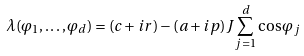<formula> <loc_0><loc_0><loc_500><loc_500>\lambda ( \varphi _ { 1 } , \dots , \varphi _ { d } ) = ( c + i r ) - ( a + i p ) J \sum _ { j = 1 } ^ { d } \cos \varphi _ { j }</formula> 